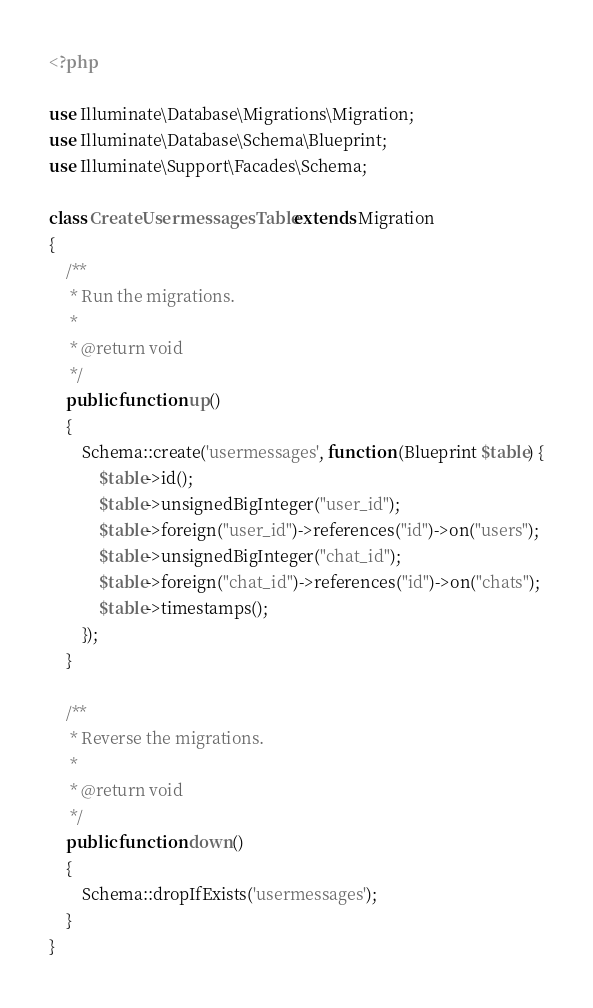Convert code to text. <code><loc_0><loc_0><loc_500><loc_500><_PHP_><?php

use Illuminate\Database\Migrations\Migration;
use Illuminate\Database\Schema\Blueprint;
use Illuminate\Support\Facades\Schema;

class CreateUsermessagesTable extends Migration
{
    /**
     * Run the migrations.
     *
     * @return void
     */
    public function up()
    {
        Schema::create('usermessages', function (Blueprint $table) {
            $table->id();
            $table->unsignedBigInteger("user_id");
            $table->foreign("user_id")->references("id")->on("users");
            $table->unsignedBigInteger("chat_id");
            $table->foreign("chat_id")->references("id")->on("chats");
            $table->timestamps();
        });
    }

    /**
     * Reverse the migrations.
     *
     * @return void
     */
    public function down()
    {
        Schema::dropIfExists('usermessages');
    }
}
</code> 